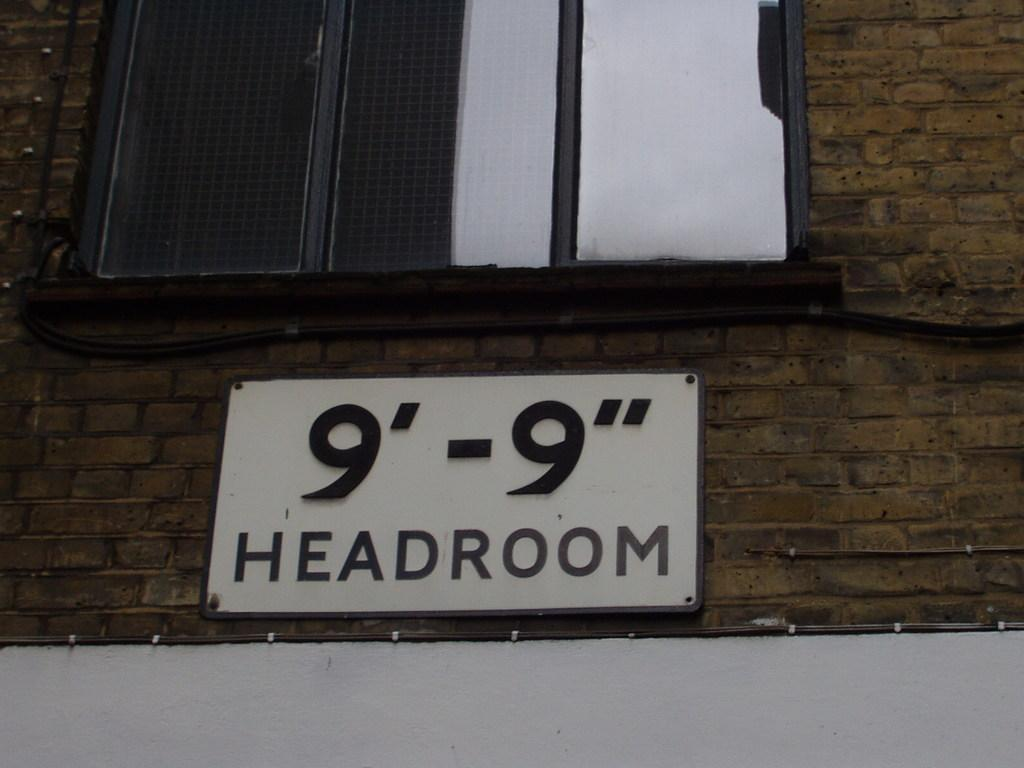What can be seen in the image that provides a view of the outside? There is a window in the image that provides a view of the outside. What is located on the wall in the image? There is a name board on the wall in the image. How many geese are sitting on the name board in the image? There are no geese present in the image, and therefore no geese are sitting on the name board. What type of pencil is being used to write on the name board in the image? There is no pencil visible in the image, and the name board does not appear to have any writing on it. 